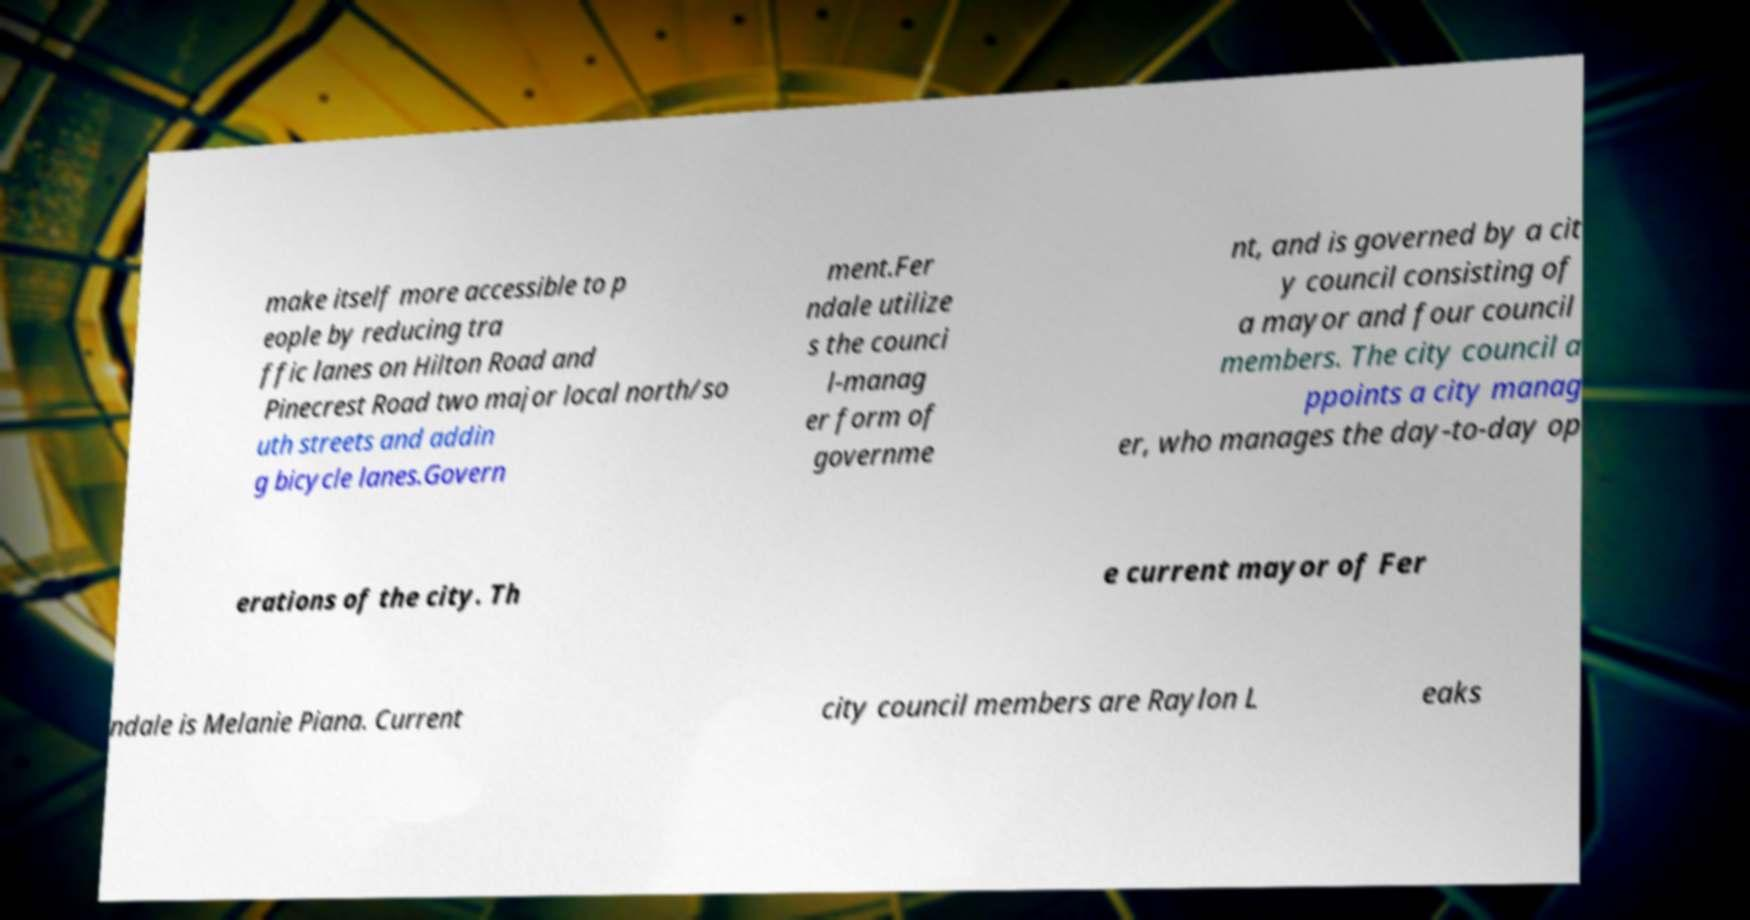Could you extract and type out the text from this image? make itself more accessible to p eople by reducing tra ffic lanes on Hilton Road and Pinecrest Road two major local north/so uth streets and addin g bicycle lanes.Govern ment.Fer ndale utilize s the counci l-manag er form of governme nt, and is governed by a cit y council consisting of a mayor and four council members. The city council a ppoints a city manag er, who manages the day-to-day op erations of the city. Th e current mayor of Fer ndale is Melanie Piana. Current city council members are Raylon L eaks 